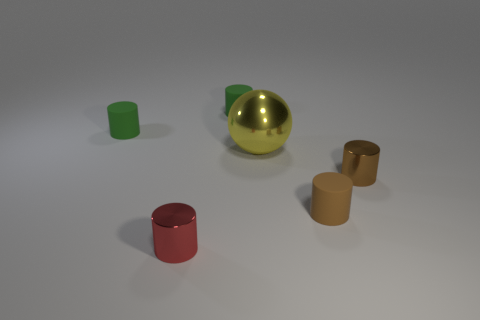The other metallic thing that is the same shape as the small red metallic object is what color?
Keep it short and to the point. Brown. There is a small red object that is the same shape as the brown rubber object; what material is it?
Provide a succinct answer. Metal. Are there any other things that are the same size as the yellow metallic object?
Keep it short and to the point. No. Is the shape of the matte object that is to the right of the metallic ball the same as the green thing that is to the right of the red metallic cylinder?
Offer a very short reply. Yes. Is the number of small red shiny objects behind the yellow shiny object less than the number of tiny cylinders on the right side of the tiny red metal thing?
Keep it short and to the point. Yes. What number of other objects are there of the same shape as the brown matte thing?
Your answer should be compact. 4. There is a big yellow thing that is made of the same material as the red cylinder; what shape is it?
Give a very brief answer. Sphere. The cylinder that is behind the tiny brown metallic object and right of the red object is what color?
Offer a terse response. Green. Does the brown cylinder in front of the brown metallic object have the same material as the large thing?
Ensure brevity in your answer.  No. Is the number of tiny red objects that are behind the sphere less than the number of rubber objects?
Keep it short and to the point. Yes. 